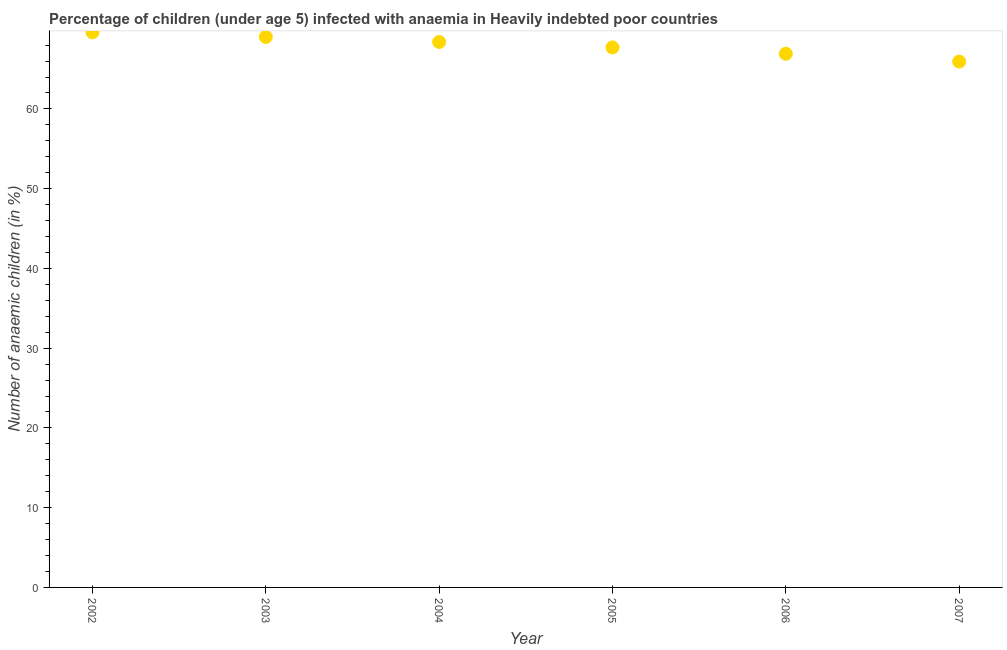What is the number of anaemic children in 2002?
Offer a very short reply. 69.61. Across all years, what is the maximum number of anaemic children?
Your response must be concise. 69.61. Across all years, what is the minimum number of anaemic children?
Your response must be concise. 65.93. In which year was the number of anaemic children maximum?
Ensure brevity in your answer.  2002. What is the sum of the number of anaemic children?
Keep it short and to the point. 407.59. What is the difference between the number of anaemic children in 2004 and 2006?
Offer a terse response. 1.48. What is the average number of anaemic children per year?
Make the answer very short. 67.93. What is the median number of anaemic children?
Make the answer very short. 68.05. What is the ratio of the number of anaemic children in 2002 to that in 2003?
Your response must be concise. 1.01. Is the number of anaemic children in 2006 less than that in 2007?
Make the answer very short. No. Is the difference between the number of anaemic children in 2004 and 2006 greater than the difference between any two years?
Give a very brief answer. No. What is the difference between the highest and the second highest number of anaemic children?
Make the answer very short. 0.58. Is the sum of the number of anaemic children in 2003 and 2004 greater than the maximum number of anaemic children across all years?
Your response must be concise. Yes. What is the difference between the highest and the lowest number of anaemic children?
Keep it short and to the point. 3.67. In how many years, is the number of anaemic children greater than the average number of anaemic children taken over all years?
Your response must be concise. 3. Are the values on the major ticks of Y-axis written in scientific E-notation?
Your answer should be compact. No. Does the graph contain grids?
Provide a short and direct response. No. What is the title of the graph?
Make the answer very short. Percentage of children (under age 5) infected with anaemia in Heavily indebted poor countries. What is the label or title of the X-axis?
Offer a very short reply. Year. What is the label or title of the Y-axis?
Offer a very short reply. Number of anaemic children (in %). What is the Number of anaemic children (in %) in 2002?
Offer a terse response. 69.61. What is the Number of anaemic children (in %) in 2003?
Your answer should be compact. 69.02. What is the Number of anaemic children (in %) in 2004?
Keep it short and to the point. 68.39. What is the Number of anaemic children (in %) in 2005?
Your answer should be very brief. 67.71. What is the Number of anaemic children (in %) in 2006?
Ensure brevity in your answer.  66.92. What is the Number of anaemic children (in %) in 2007?
Your answer should be compact. 65.93. What is the difference between the Number of anaemic children (in %) in 2002 and 2003?
Keep it short and to the point. 0.58. What is the difference between the Number of anaemic children (in %) in 2002 and 2004?
Your response must be concise. 1.21. What is the difference between the Number of anaemic children (in %) in 2002 and 2005?
Offer a very short reply. 1.9. What is the difference between the Number of anaemic children (in %) in 2002 and 2006?
Offer a terse response. 2.69. What is the difference between the Number of anaemic children (in %) in 2002 and 2007?
Your answer should be compact. 3.67. What is the difference between the Number of anaemic children (in %) in 2003 and 2004?
Offer a terse response. 0.63. What is the difference between the Number of anaemic children (in %) in 2003 and 2005?
Provide a succinct answer. 1.31. What is the difference between the Number of anaemic children (in %) in 2003 and 2006?
Give a very brief answer. 2.11. What is the difference between the Number of anaemic children (in %) in 2003 and 2007?
Offer a very short reply. 3.09. What is the difference between the Number of anaemic children (in %) in 2004 and 2005?
Give a very brief answer. 0.68. What is the difference between the Number of anaemic children (in %) in 2004 and 2006?
Provide a short and direct response. 1.48. What is the difference between the Number of anaemic children (in %) in 2004 and 2007?
Give a very brief answer. 2.46. What is the difference between the Number of anaemic children (in %) in 2005 and 2006?
Make the answer very short. 0.79. What is the difference between the Number of anaemic children (in %) in 2005 and 2007?
Ensure brevity in your answer.  1.78. What is the difference between the Number of anaemic children (in %) in 2006 and 2007?
Make the answer very short. 0.98. What is the ratio of the Number of anaemic children (in %) in 2002 to that in 2005?
Your answer should be compact. 1.03. What is the ratio of the Number of anaemic children (in %) in 2002 to that in 2007?
Provide a succinct answer. 1.06. What is the ratio of the Number of anaemic children (in %) in 2003 to that in 2006?
Your response must be concise. 1.03. What is the ratio of the Number of anaemic children (in %) in 2003 to that in 2007?
Keep it short and to the point. 1.05. What is the ratio of the Number of anaemic children (in %) in 2004 to that in 2005?
Keep it short and to the point. 1.01. What is the ratio of the Number of anaemic children (in %) in 2004 to that in 2006?
Keep it short and to the point. 1.02. What is the ratio of the Number of anaemic children (in %) in 2004 to that in 2007?
Keep it short and to the point. 1.04. What is the ratio of the Number of anaemic children (in %) in 2005 to that in 2007?
Offer a very short reply. 1.03. What is the ratio of the Number of anaemic children (in %) in 2006 to that in 2007?
Your answer should be very brief. 1.01. 